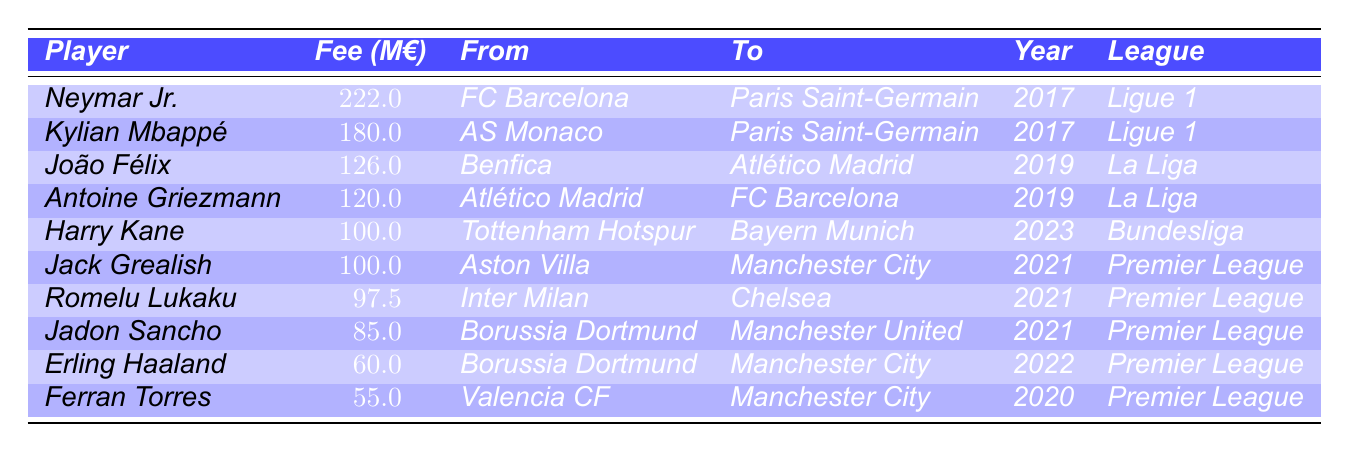What is the highest player transfer fee listed in the table? The table displays player transfer fees, and scanning through the values reveals that the highest transfer fee is 222 million euros for Neymar Jr.
Answer: 222 million euros Which league has the most players represented in the table? By examining the table, it shows that the Premier League has the most players listed, with four players compared to one or two for other leagues.
Answer: Premier League How much was the transfer fee for Erling Haaland? The table indicates that Erling Haaland was transferred for a fee of 60 million euros when moving from Borussia Dortmund to Manchester City.
Answer: 60 million euros What is the total transfer fee for the players transferred from Ligue 1? The players transferred from Ligue 1 are Neymar Jr. and Kylian Mbappé, with their fees being 222 million euros and 180 million euros, respectively. Summing these gives 222 + 180 = 402 million euros.
Answer: 402 million euros Which player had a transfer fee of 100 million euros? Scanning the table, both Harry Kane and Jack Grealish had transfer fees listed as 100 million euros.
Answer: Harry Kane and Jack Grealish Did any players transfer to Premier League clubs for over 90 million euros? Reviewing the table, both Romelu Lukaku (97.5 million euros) and Jack Grealish (100 million euros) transferred to Premier League clubs for over 90 million euros.
Answer: Yes What is the average transfer fee of the players in the table? To find the average, sum all transfer fees in the table: 222 + 180 + 126 + 120 + 100 + 100 + 97.5 + 85 + 60 + 55 = 1,125. There are 10 players, so divide by 10 gives 1,125 / 10 = 112.5 million euros.
Answer: 112.5 million euros Which player moved from Borussia Dortmund, and what was the transfer fee? The table lists two players who moved from Borussia Dortmund: Jadon Sancho and Erling Haaland. The transfer fees are 85 million euros for Sancho and 60 million euros for Haaland.
Answer: Jadon Sancho for 85 million euros and Erling Haaland for 60 million euros How many players transferred for a fee of less than 100 million euros? Counting the fees in the table, Ferran Torres (55), Erling Haaland (60), Jadon Sancho (85), and Romelu Lukaku (97.5) have transfer fees under 100 million euros. This counts to a total of four players.
Answer: 4 players Was the transfer fee for João Félix higher than that of Romelu Lukaku? Comparing the fees in the table, João Félix had a transfer fee of 126 million euros, while Romelu Lukaku’s fee was 97.5 million euros. Since 126 million is greater than 97.5 million, the answer is yes.
Answer: Yes 